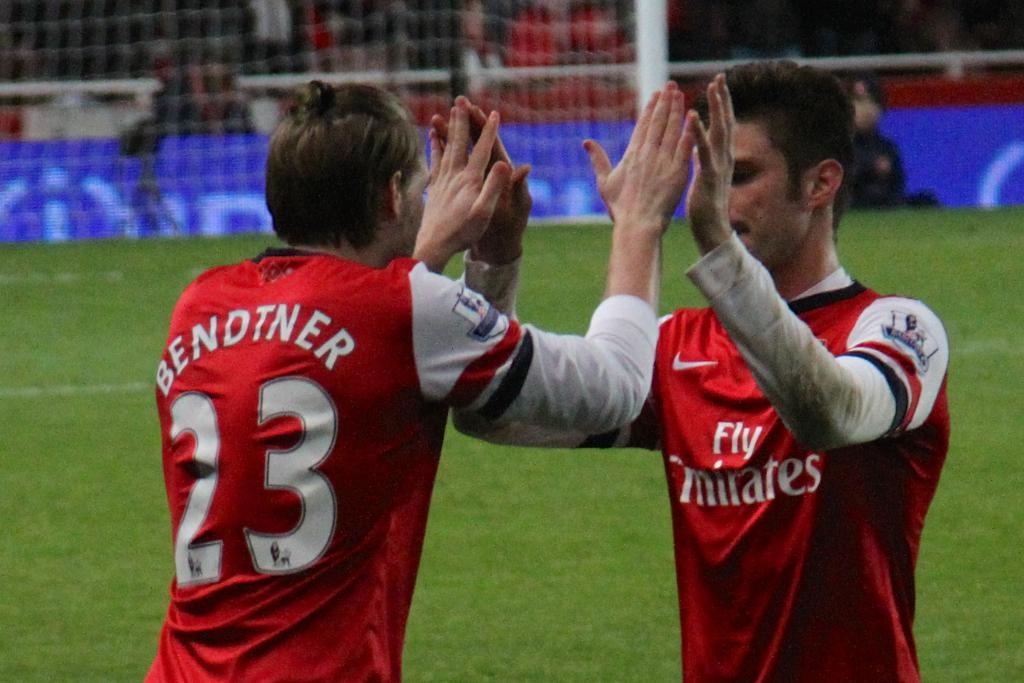<image>
Summarize the visual content of the image. Two athletes high five each other in red and white jerseys which one says Bendtner 23 on the back. 